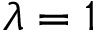Convert formula to latex. <formula><loc_0><loc_0><loc_500><loc_500>\lambda = 1</formula> 